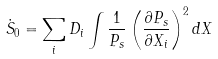Convert formula to latex. <formula><loc_0><loc_0><loc_500><loc_500>\dot { S } _ { 0 } = \sum _ { i } D _ { i } \int \frac { 1 } { P _ { s } } \left ( \frac { \partial P _ { s } } { \partial X _ { i } } \right ) ^ { 2 } d X</formula> 